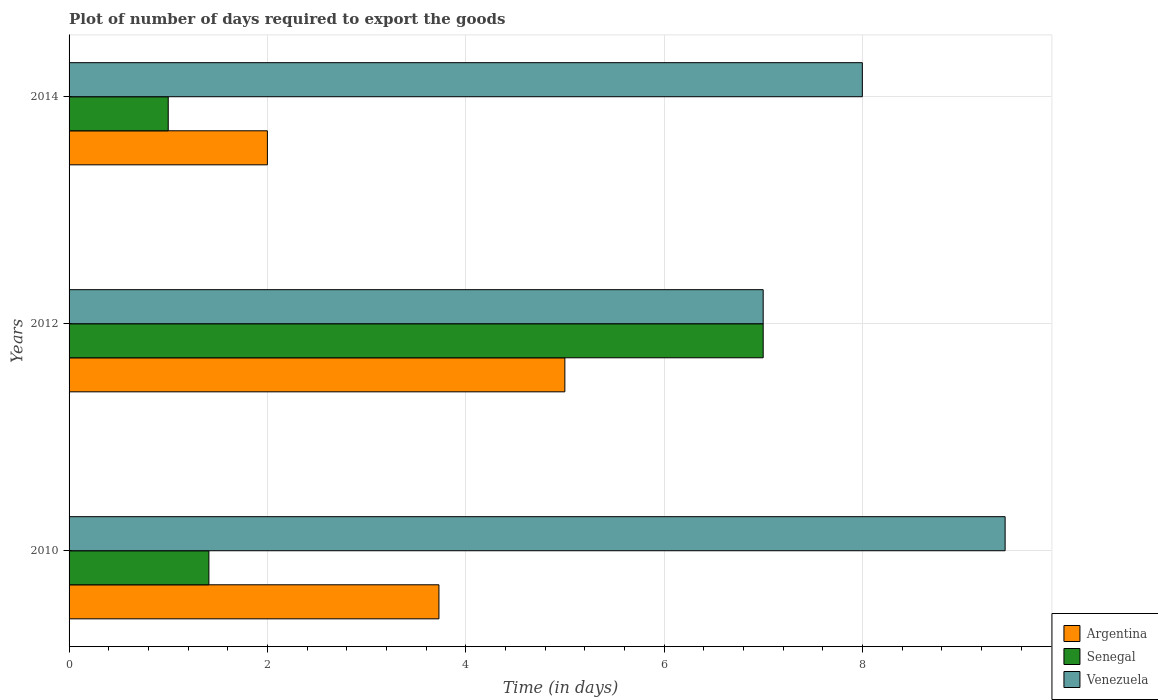Are the number of bars on each tick of the Y-axis equal?
Offer a terse response. Yes. In how many cases, is the number of bars for a given year not equal to the number of legend labels?
Keep it short and to the point. 0. What is the time required to export goods in Senegal in 2010?
Your answer should be very brief. 1.41. In which year was the time required to export goods in Argentina maximum?
Provide a short and direct response. 2012. In which year was the time required to export goods in Senegal minimum?
Your response must be concise. 2014. What is the total time required to export goods in Senegal in the graph?
Make the answer very short. 9.41. What is the difference between the time required to export goods in Argentina in 2010 and that in 2014?
Your response must be concise. 1.73. What is the difference between the time required to export goods in Argentina in 2010 and the time required to export goods in Venezuela in 2012?
Offer a very short reply. -3.27. What is the average time required to export goods in Argentina per year?
Offer a terse response. 3.58. In how many years, is the time required to export goods in Senegal greater than 6.8 days?
Your answer should be compact. 1. What is the ratio of the time required to export goods in Senegal in 2010 to that in 2014?
Keep it short and to the point. 1.41. Is the time required to export goods in Venezuela in 2012 less than that in 2014?
Your response must be concise. Yes. What is the difference between the highest and the second highest time required to export goods in Venezuela?
Ensure brevity in your answer.  1.44. What is the difference between the highest and the lowest time required to export goods in Venezuela?
Make the answer very short. 2.44. In how many years, is the time required to export goods in Senegal greater than the average time required to export goods in Senegal taken over all years?
Keep it short and to the point. 1. Is the sum of the time required to export goods in Argentina in 2012 and 2014 greater than the maximum time required to export goods in Venezuela across all years?
Keep it short and to the point. No. What does the 1st bar from the top in 2010 represents?
Keep it short and to the point. Venezuela. What does the 3rd bar from the bottom in 2012 represents?
Offer a very short reply. Venezuela. How many bars are there?
Provide a succinct answer. 9. Are all the bars in the graph horizontal?
Provide a short and direct response. Yes. Are the values on the major ticks of X-axis written in scientific E-notation?
Your response must be concise. No. Does the graph contain any zero values?
Provide a short and direct response. No. Does the graph contain grids?
Ensure brevity in your answer.  Yes. How many legend labels are there?
Keep it short and to the point. 3. How are the legend labels stacked?
Give a very brief answer. Vertical. What is the title of the graph?
Give a very brief answer. Plot of number of days required to export the goods. What is the label or title of the X-axis?
Your answer should be very brief. Time (in days). What is the Time (in days) of Argentina in 2010?
Give a very brief answer. 3.73. What is the Time (in days) in Senegal in 2010?
Provide a short and direct response. 1.41. What is the Time (in days) in Venezuela in 2010?
Provide a succinct answer. 9.44. What is the Time (in days) of Argentina in 2014?
Your response must be concise. 2. What is the Time (in days) of Senegal in 2014?
Give a very brief answer. 1. Across all years, what is the maximum Time (in days) in Senegal?
Offer a terse response. 7. Across all years, what is the maximum Time (in days) of Venezuela?
Your answer should be very brief. 9.44. What is the total Time (in days) in Argentina in the graph?
Provide a succinct answer. 10.73. What is the total Time (in days) of Senegal in the graph?
Offer a very short reply. 9.41. What is the total Time (in days) in Venezuela in the graph?
Your answer should be compact. 24.44. What is the difference between the Time (in days) in Argentina in 2010 and that in 2012?
Give a very brief answer. -1.27. What is the difference between the Time (in days) of Senegal in 2010 and that in 2012?
Your answer should be very brief. -5.59. What is the difference between the Time (in days) in Venezuela in 2010 and that in 2012?
Offer a terse response. 2.44. What is the difference between the Time (in days) in Argentina in 2010 and that in 2014?
Offer a terse response. 1.73. What is the difference between the Time (in days) of Senegal in 2010 and that in 2014?
Provide a short and direct response. 0.41. What is the difference between the Time (in days) of Venezuela in 2010 and that in 2014?
Provide a succinct answer. 1.44. What is the difference between the Time (in days) of Argentina in 2012 and that in 2014?
Your response must be concise. 3. What is the difference between the Time (in days) in Argentina in 2010 and the Time (in days) in Senegal in 2012?
Your answer should be very brief. -3.27. What is the difference between the Time (in days) in Argentina in 2010 and the Time (in days) in Venezuela in 2012?
Provide a succinct answer. -3.27. What is the difference between the Time (in days) of Senegal in 2010 and the Time (in days) of Venezuela in 2012?
Ensure brevity in your answer.  -5.59. What is the difference between the Time (in days) in Argentina in 2010 and the Time (in days) in Senegal in 2014?
Provide a succinct answer. 2.73. What is the difference between the Time (in days) of Argentina in 2010 and the Time (in days) of Venezuela in 2014?
Offer a terse response. -4.27. What is the difference between the Time (in days) in Senegal in 2010 and the Time (in days) in Venezuela in 2014?
Provide a short and direct response. -6.59. What is the difference between the Time (in days) of Argentina in 2012 and the Time (in days) of Senegal in 2014?
Your answer should be very brief. 4. What is the average Time (in days) in Argentina per year?
Offer a very short reply. 3.58. What is the average Time (in days) in Senegal per year?
Provide a short and direct response. 3.14. What is the average Time (in days) in Venezuela per year?
Offer a terse response. 8.15. In the year 2010, what is the difference between the Time (in days) of Argentina and Time (in days) of Senegal?
Provide a succinct answer. 2.32. In the year 2010, what is the difference between the Time (in days) in Argentina and Time (in days) in Venezuela?
Provide a succinct answer. -5.71. In the year 2010, what is the difference between the Time (in days) of Senegal and Time (in days) of Venezuela?
Ensure brevity in your answer.  -8.03. In the year 2012, what is the difference between the Time (in days) in Argentina and Time (in days) in Senegal?
Provide a short and direct response. -2. In the year 2012, what is the difference between the Time (in days) in Argentina and Time (in days) in Venezuela?
Provide a succinct answer. -2. In the year 2012, what is the difference between the Time (in days) in Senegal and Time (in days) in Venezuela?
Your response must be concise. 0. In the year 2014, what is the difference between the Time (in days) of Senegal and Time (in days) of Venezuela?
Offer a terse response. -7. What is the ratio of the Time (in days) of Argentina in 2010 to that in 2012?
Your answer should be compact. 0.75. What is the ratio of the Time (in days) in Senegal in 2010 to that in 2012?
Keep it short and to the point. 0.2. What is the ratio of the Time (in days) of Venezuela in 2010 to that in 2012?
Keep it short and to the point. 1.35. What is the ratio of the Time (in days) of Argentina in 2010 to that in 2014?
Provide a succinct answer. 1.86. What is the ratio of the Time (in days) in Senegal in 2010 to that in 2014?
Ensure brevity in your answer.  1.41. What is the ratio of the Time (in days) in Venezuela in 2010 to that in 2014?
Keep it short and to the point. 1.18. What is the ratio of the Time (in days) of Argentina in 2012 to that in 2014?
Ensure brevity in your answer.  2.5. What is the ratio of the Time (in days) of Senegal in 2012 to that in 2014?
Give a very brief answer. 7. What is the difference between the highest and the second highest Time (in days) in Argentina?
Your response must be concise. 1.27. What is the difference between the highest and the second highest Time (in days) of Senegal?
Your response must be concise. 5.59. What is the difference between the highest and the second highest Time (in days) of Venezuela?
Offer a very short reply. 1.44. What is the difference between the highest and the lowest Time (in days) of Argentina?
Ensure brevity in your answer.  3. What is the difference between the highest and the lowest Time (in days) in Venezuela?
Provide a succinct answer. 2.44. 